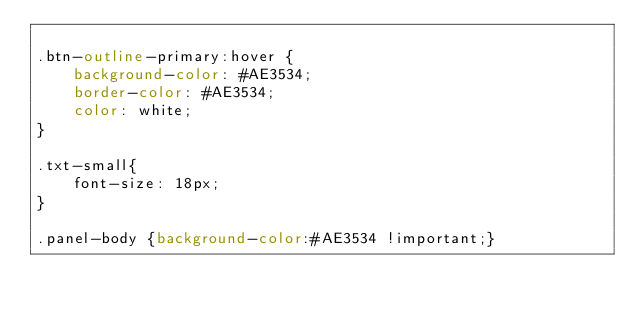<code> <loc_0><loc_0><loc_500><loc_500><_CSS_>
.btn-outline-primary:hover {
    background-color: #AE3534;
    border-color: #AE3534;
    color: white;
}

.txt-small{
    font-size: 18px;
}

.panel-body {background-color:#AE3534 !important;}</code> 